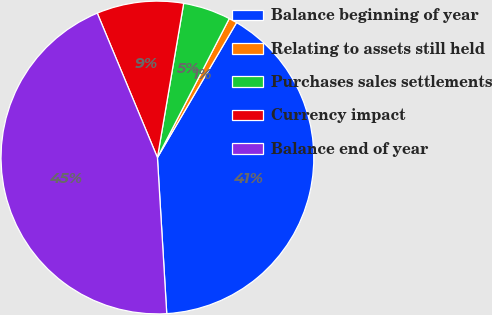Convert chart. <chart><loc_0><loc_0><loc_500><loc_500><pie_chart><fcel>Balance beginning of year<fcel>Relating to assets still held<fcel>Purchases sales settlements<fcel>Currency impact<fcel>Balance end of year<nl><fcel>40.61%<fcel>0.85%<fcel>4.91%<fcel>8.97%<fcel>44.67%<nl></chart> 